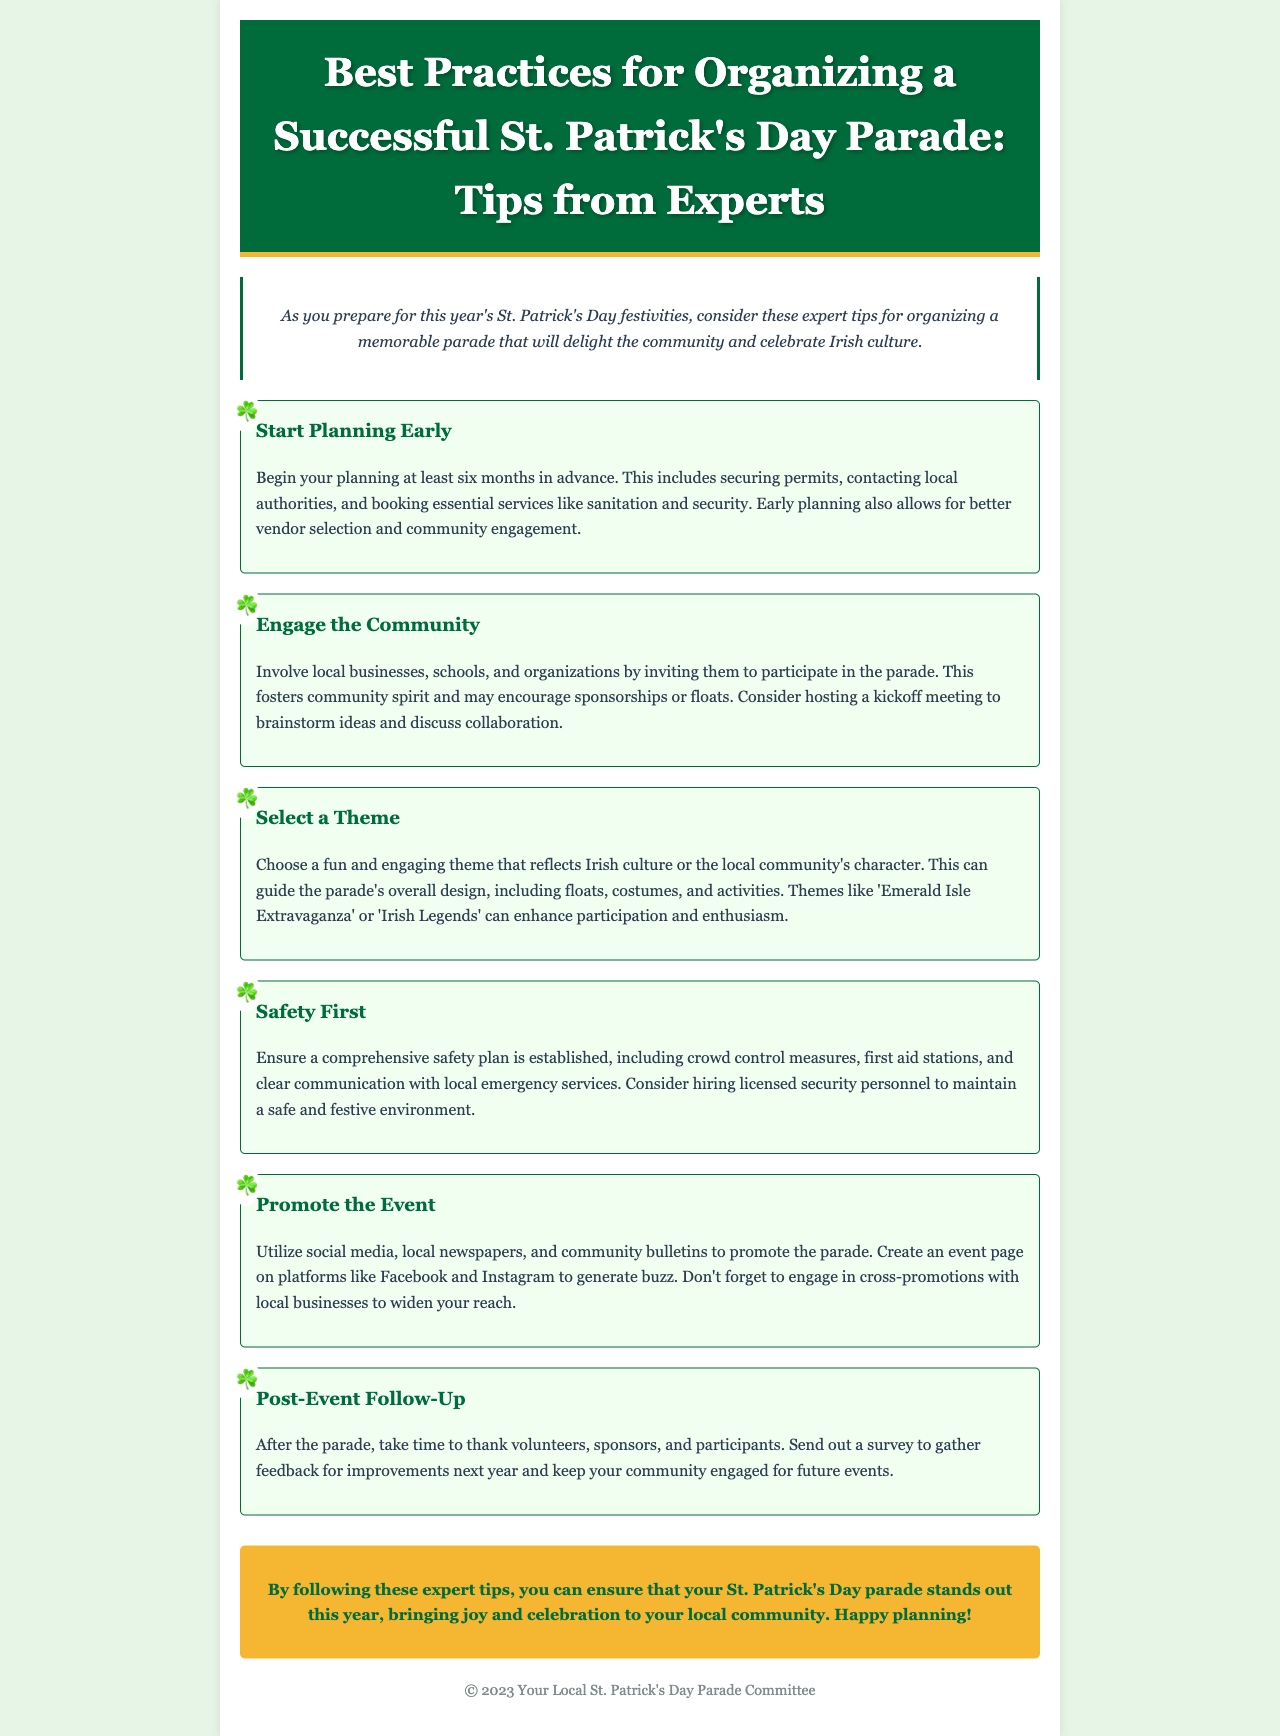What is the title of the newsletter? The title of the newsletter is found in the header of the document, announcing the subject matter clearly.
Answer: Best Practices for Organizing a Successful St. Patrick's Day Parade: Tips from Experts How far in advance should planning begin? The document states a specific timeframe for planning, highlighting its importance for success.
Answer: six months What is one way to engage the community? The document suggests a method for community involvement that can enhance participation and support for the event.
Answer: hosting a kickoff meeting What should be included in the safety plan? The safety plan is detailed in the newsletter, indicating essential elements for ensuring safety during the event.
Answer: crowd control measures What color are the section headers in the tips? The document outlines color details for distinguishing various sections, emphasizing the design aspect.
Answer: green What type of event promotion is mentioned? In the newsletter, specific channels for promoting the parade are outlined to reach a wider audience effectively.
Answer: social media What is a suggested theme for the parade? The newsletter provides examples of themes, aiding in the parade's overall design and creativity.
Answer: Emerald Isle Extravaganza What is the conclusion encouraging organizers to do? The conclusion summarizes the main goal of the tips by motivating a positive outcome for the parade.
Answer: ensure that your St. Patrick's Day parade stands out What is the primary purpose of the newsletter? The newsletter serves a specific purpose based on its content and structure tailored to the event organization.
Answer: provide tips for organizing a successful parade 